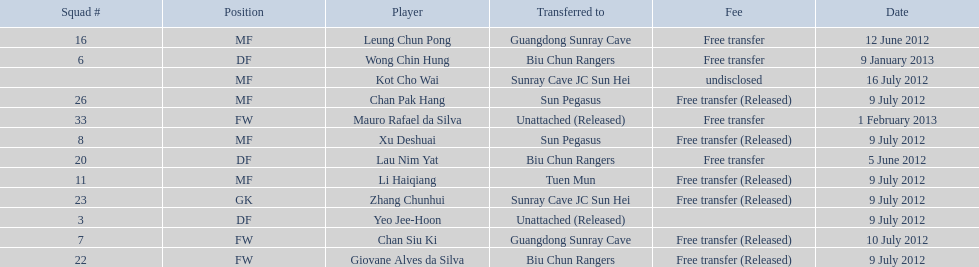Which players played during the 2012-13 south china aa season? Lau Nim Yat, Leung Chun Pong, Yeo Jee-Hoon, Xu Deshuai, Li Haiqiang, Giovane Alves da Silva, Zhang Chunhui, Chan Pak Hang, Chan Siu Ki, Kot Cho Wai, Wong Chin Hung, Mauro Rafael da Silva. Of these, which were free transfers that were not released? Lau Nim Yat, Leung Chun Pong, Wong Chin Hung, Mauro Rafael da Silva. Of these, which were in squad # 6? Wong Chin Hung. What was the date of his transfer? 9 January 2013. 